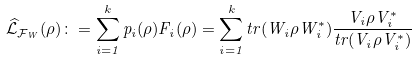Convert formula to latex. <formula><loc_0><loc_0><loc_500><loc_500>\widehat { \mathcal { L } } _ { \mathcal { F } _ { W } } ( \rho ) \colon = \sum _ { i = 1 } ^ { k } p _ { i } ( \rho ) F _ { i } ( \rho ) = \sum _ { i = 1 } ^ { k } t r ( W _ { i } \rho W _ { i } ^ { * } ) \frac { V _ { i } \rho V _ { i } ^ { * } } { t r ( V _ { i } \rho V _ { i } ^ { * } ) }</formula> 